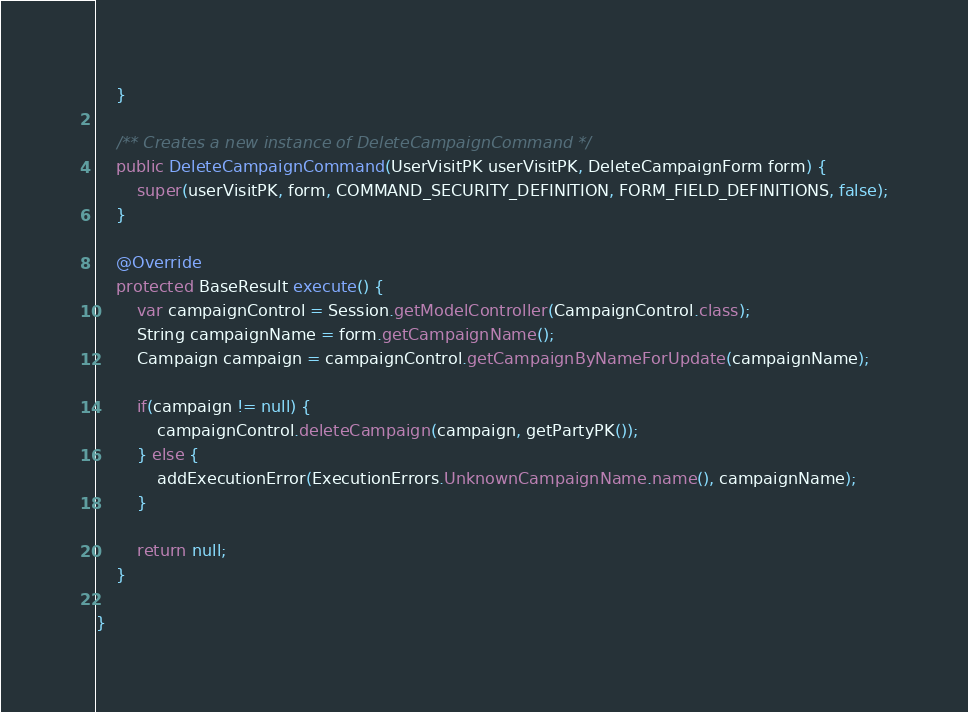<code> <loc_0><loc_0><loc_500><loc_500><_Java_>    }
    
    /** Creates a new instance of DeleteCampaignCommand */
    public DeleteCampaignCommand(UserVisitPK userVisitPK, DeleteCampaignForm form) {
        super(userVisitPK, form, COMMAND_SECURITY_DEFINITION, FORM_FIELD_DEFINITIONS, false);
    }
    
    @Override
    protected BaseResult execute() {
        var campaignControl = Session.getModelController(CampaignControl.class);
        String campaignName = form.getCampaignName();
        Campaign campaign = campaignControl.getCampaignByNameForUpdate(campaignName);
        
        if(campaign != null) {
            campaignControl.deleteCampaign(campaign, getPartyPK());
        } else {
            addExecutionError(ExecutionErrors.UnknownCampaignName.name(), campaignName);
        }
        
        return null;
    }
    
}
</code> 